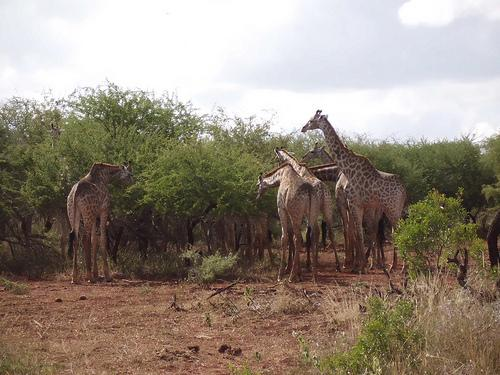Identify the main subject in the image and provide a brief description of their actions. A giraffe with brown and white spots is eating leaves from a tree, with several other giraffes nearby in the wilderness. Write a concise description of the image, emphasizing the main subject and their actions. A brown and white giraffe is eating leaves from a tree, amongst a group of giraffes standing in a dry, wilderness setting. Explain the key components of the image, including the subject and their environment. A group of giraffes, with the primary giraffe eating from a tree, are situated in the wilderness, surrounded by trees, dry land, and a light blue sky. Describe the environment and setting of the image. In the wilderness, giraffes are gathered around trees in dry terrain, under a light blue sky with wide white clouds. Describe the primary object and its surroundings in the picture. A brown and white giraffe is eating from a tree, surrounded by other giraffes and green trees on dry, patchy ground with branches on the ground. State the activity occurring in the image and its location. A giraffe is feeding from a tree among a group of giraffes and trees in the wilderness, on dry ground with patches of dirt. Provide a detailed description of the primary object in the image. A brown and white giraffe in the wilderness is eating leaves from a tall tree, surrounded by several other giraffes standing in a group. Explain the actions of the primary subject in the image. The main giraffe is extending its long neck to eat leaves from a tree branch, while other giraffes are feeding nearby. Mention the main elements in the picture and their features. Giraffes with long necks, brown and beige spots are eating from green trees, standing on dry ground with patches of dirt and branches. Write a description of the image focusing on the scenery. Giraffes are standing in front of a row of trees on brown dirt, with branches and yellow growth, under a sky filled with blue hues and white clouds. 